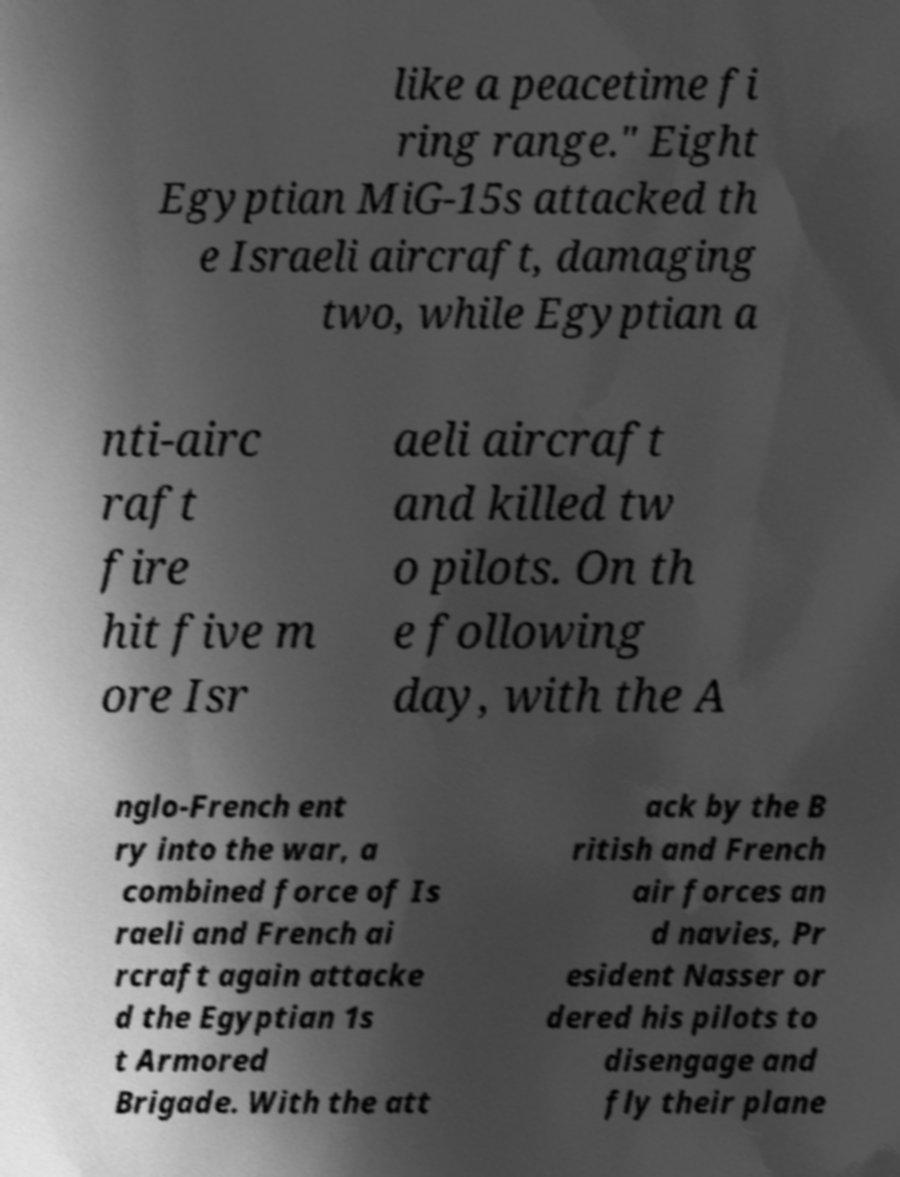Can you accurately transcribe the text from the provided image for me? like a peacetime fi ring range." Eight Egyptian MiG-15s attacked th e Israeli aircraft, damaging two, while Egyptian a nti-airc raft fire hit five m ore Isr aeli aircraft and killed tw o pilots. On th e following day, with the A nglo-French ent ry into the war, a combined force of Is raeli and French ai rcraft again attacke d the Egyptian 1s t Armored Brigade. With the att ack by the B ritish and French air forces an d navies, Pr esident Nasser or dered his pilots to disengage and fly their plane 